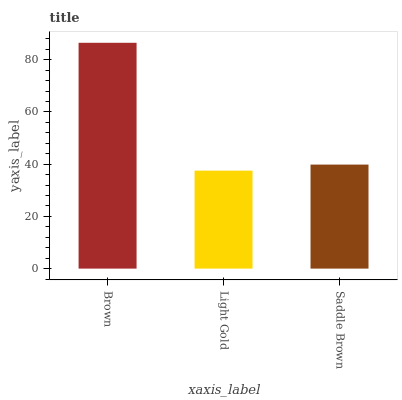Is Light Gold the minimum?
Answer yes or no. Yes. Is Brown the maximum?
Answer yes or no. Yes. Is Saddle Brown the minimum?
Answer yes or no. No. Is Saddle Brown the maximum?
Answer yes or no. No. Is Saddle Brown greater than Light Gold?
Answer yes or no. Yes. Is Light Gold less than Saddle Brown?
Answer yes or no. Yes. Is Light Gold greater than Saddle Brown?
Answer yes or no. No. Is Saddle Brown less than Light Gold?
Answer yes or no. No. Is Saddle Brown the high median?
Answer yes or no. Yes. Is Saddle Brown the low median?
Answer yes or no. Yes. Is Brown the high median?
Answer yes or no. No. Is Brown the low median?
Answer yes or no. No. 